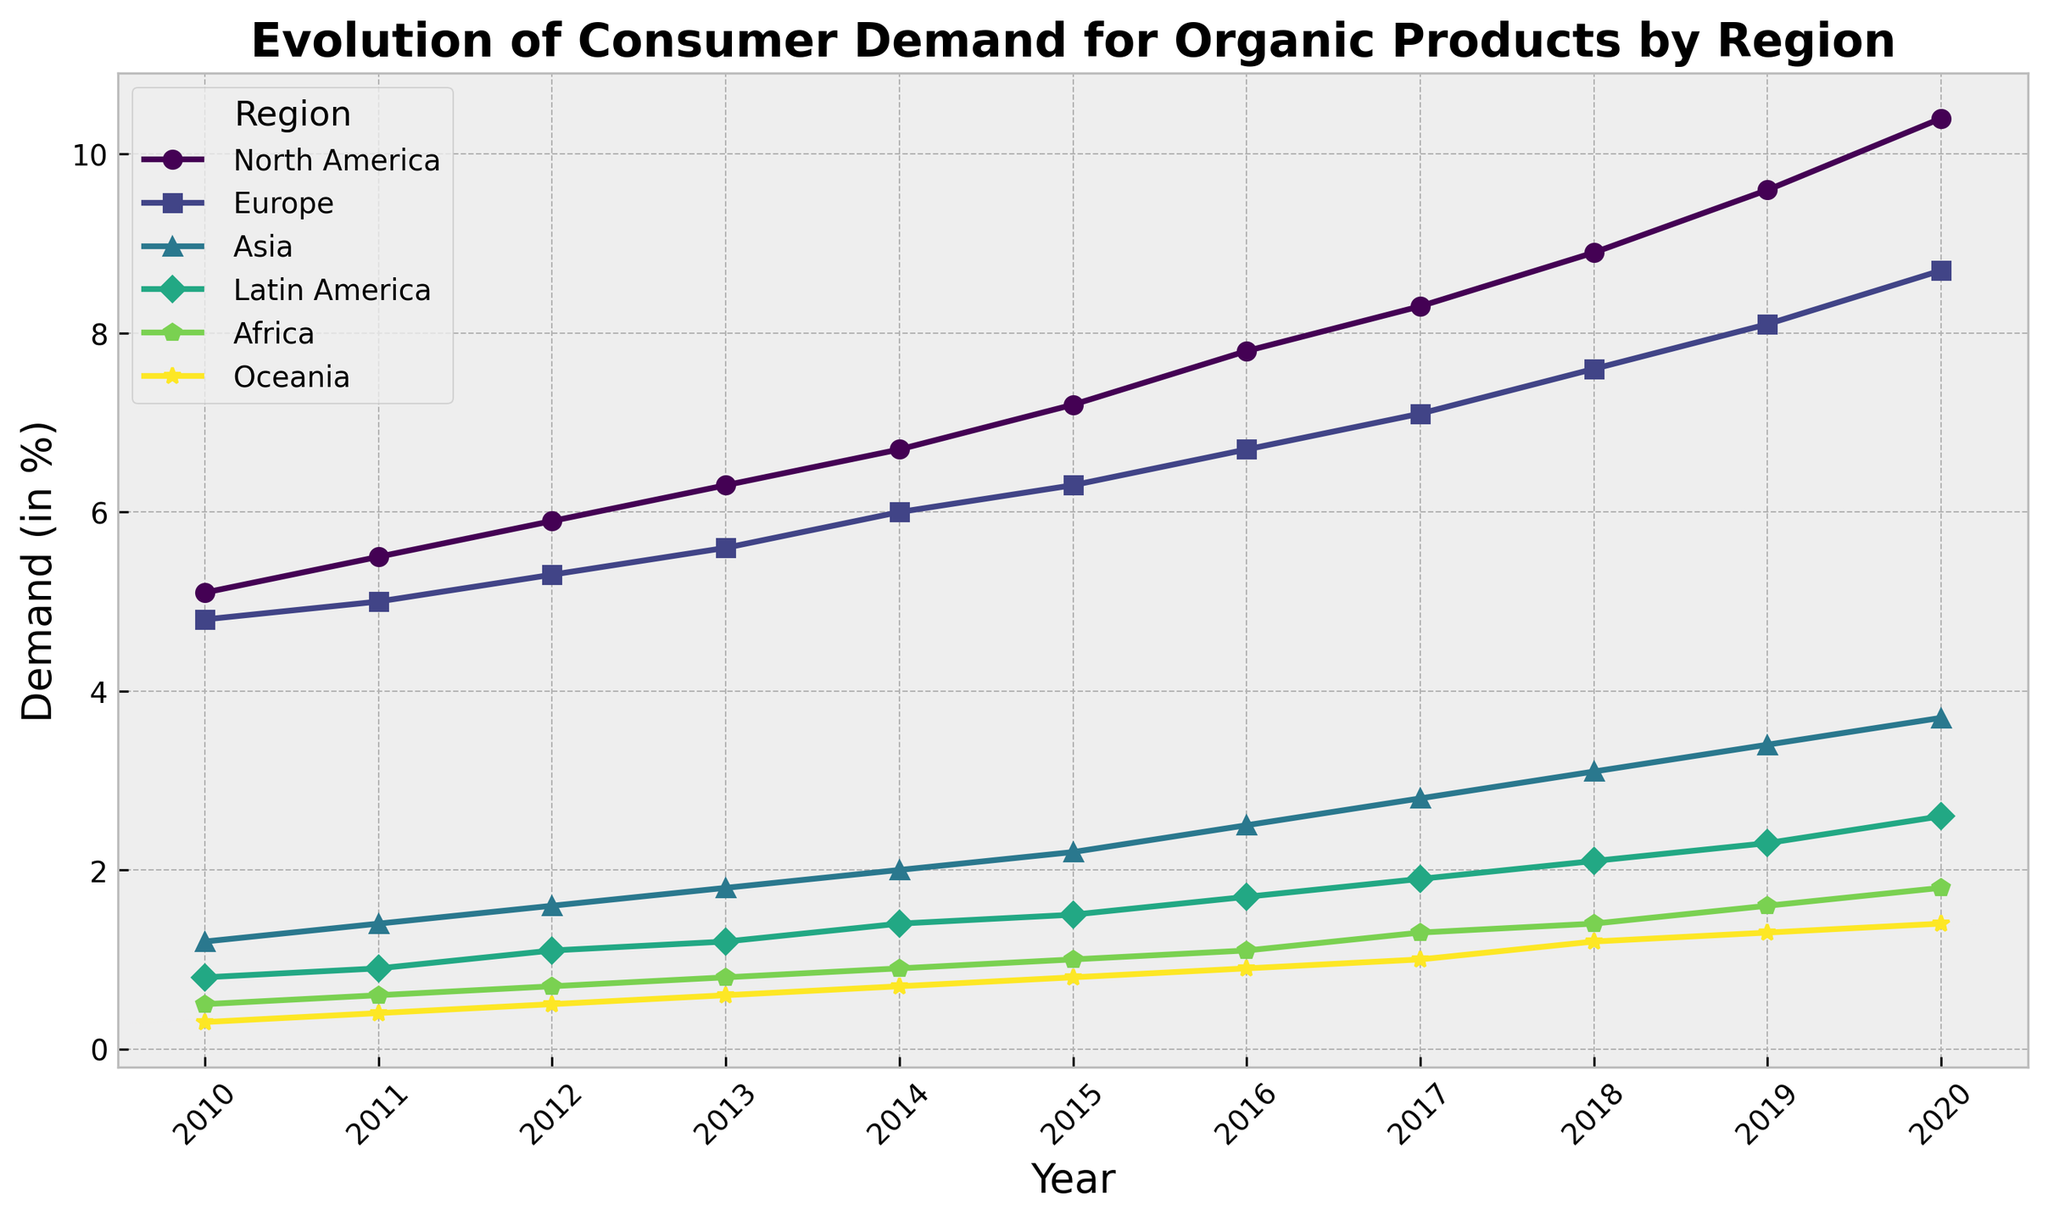What year did North America's consumer demand for organic products first surpass 7%? Look at the North America line and identify when it first crosses the 7% mark on the Y-axis. This occurs between 2014 and 2015.
Answer: 2015 In which region did the demand grow the fastest between 2010 and 2020? Calculate the difference in demand for each region by subtracting the 2010 value from the 2020 value. North America increased by 5.3%, Europe by 3.9%, Asia by 2.5%, Latin America by 1.8%, Africa by 1.3%, and Oceania by 1.1%.
Answer: North America By how much did demand in Europe increase from 2010 to 2020? Subtract the 2010 value for Europe (4.8) from the 2020 value (8.7). This gives 8.7 - 4.8 = 3.9%.
Answer: 3.9% Which region had the least variation in consumer demand from 2010 to 2020? Calculate the range for each region by subtracting the minimum value from the maximum value. Oceania had the smallest range: 1.4 - 0.3 = 1.1.
Answer: Oceania How did the percentage of consumer demand in Asia in 2020 compare to Latin America in the same year? Compare the 2020 value for Asia (3.7) and Latin America (2.6). Since 3.7 is greater than 2.6, the demand in Asia is higher.
Answer: Asia is higher What is the overall trend for consumer demand in Africa from 2010 to 2020? Look at the line representing Africa, which consistently shows an upward trend from 0.5 in 2010 to 1.8 in 2020.
Answer: Increasing In which year did Latin America’s demand for organic products reach 2%? Identify the year when the value for Latin America first matches or exceeds 2%. This occurs in 2018 when the value is 2.1%.
Answer: 2018 Compare the consumer demand in North America and Europe in 2015. Look at the values for 2015 for both regions. North America is 7.2, and Europe is 6.3. Since 7.2 is greater than 6.3, North America has higher demand.
Answer: North America What is the average consumer demand for organic products in Oceania from 2010 to 2020? Add up all the annual values for Oceania from 2010 to 2020 and divide by the number of years. (0.3 + 0.4 + 0.5 + 0.6 + 0.7 + 0.8 + 0.9 + 1.0 + 1.2 + 1.3 + 1.4) / 11 = 0.8.
Answer: 0.8% Which region showed the most significant growth in consumer demand from 2017 to 2018? Subtract the 2017 value from the 2018 value for each region: North America (0.6), Europe (0.5), Asia (0.3), Latin America (0.2), Africa (0.1), and Oceania (0.2). North America had the highest growth.
Answer: North America 